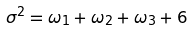Convert formula to latex. <formula><loc_0><loc_0><loc_500><loc_500>\sigma ^ { 2 } = \omega _ { 1 } + \omega _ { 2 } + \omega _ { 3 } + 6</formula> 